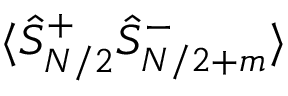Convert formula to latex. <formula><loc_0><loc_0><loc_500><loc_500>\langle \hat { S } _ { N / 2 } ^ { + } \hat { S } _ { N / 2 + m } ^ { - } \rangle</formula> 